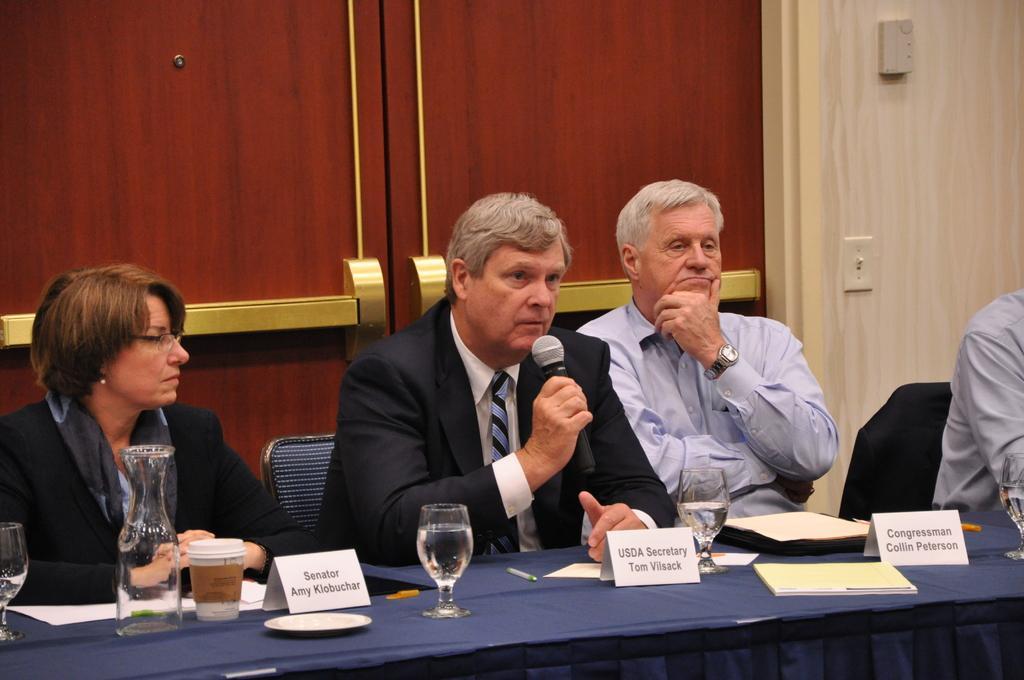How would you summarize this image in a sentence or two? As we can see in the image there is a wall, cupboards, few people sitting on chairs and there is a table. On table there are glasses, bottle and papers. The man sitting in the middle is holding a mic. 